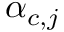<formula> <loc_0><loc_0><loc_500><loc_500>\alpha _ { c , j }</formula> 